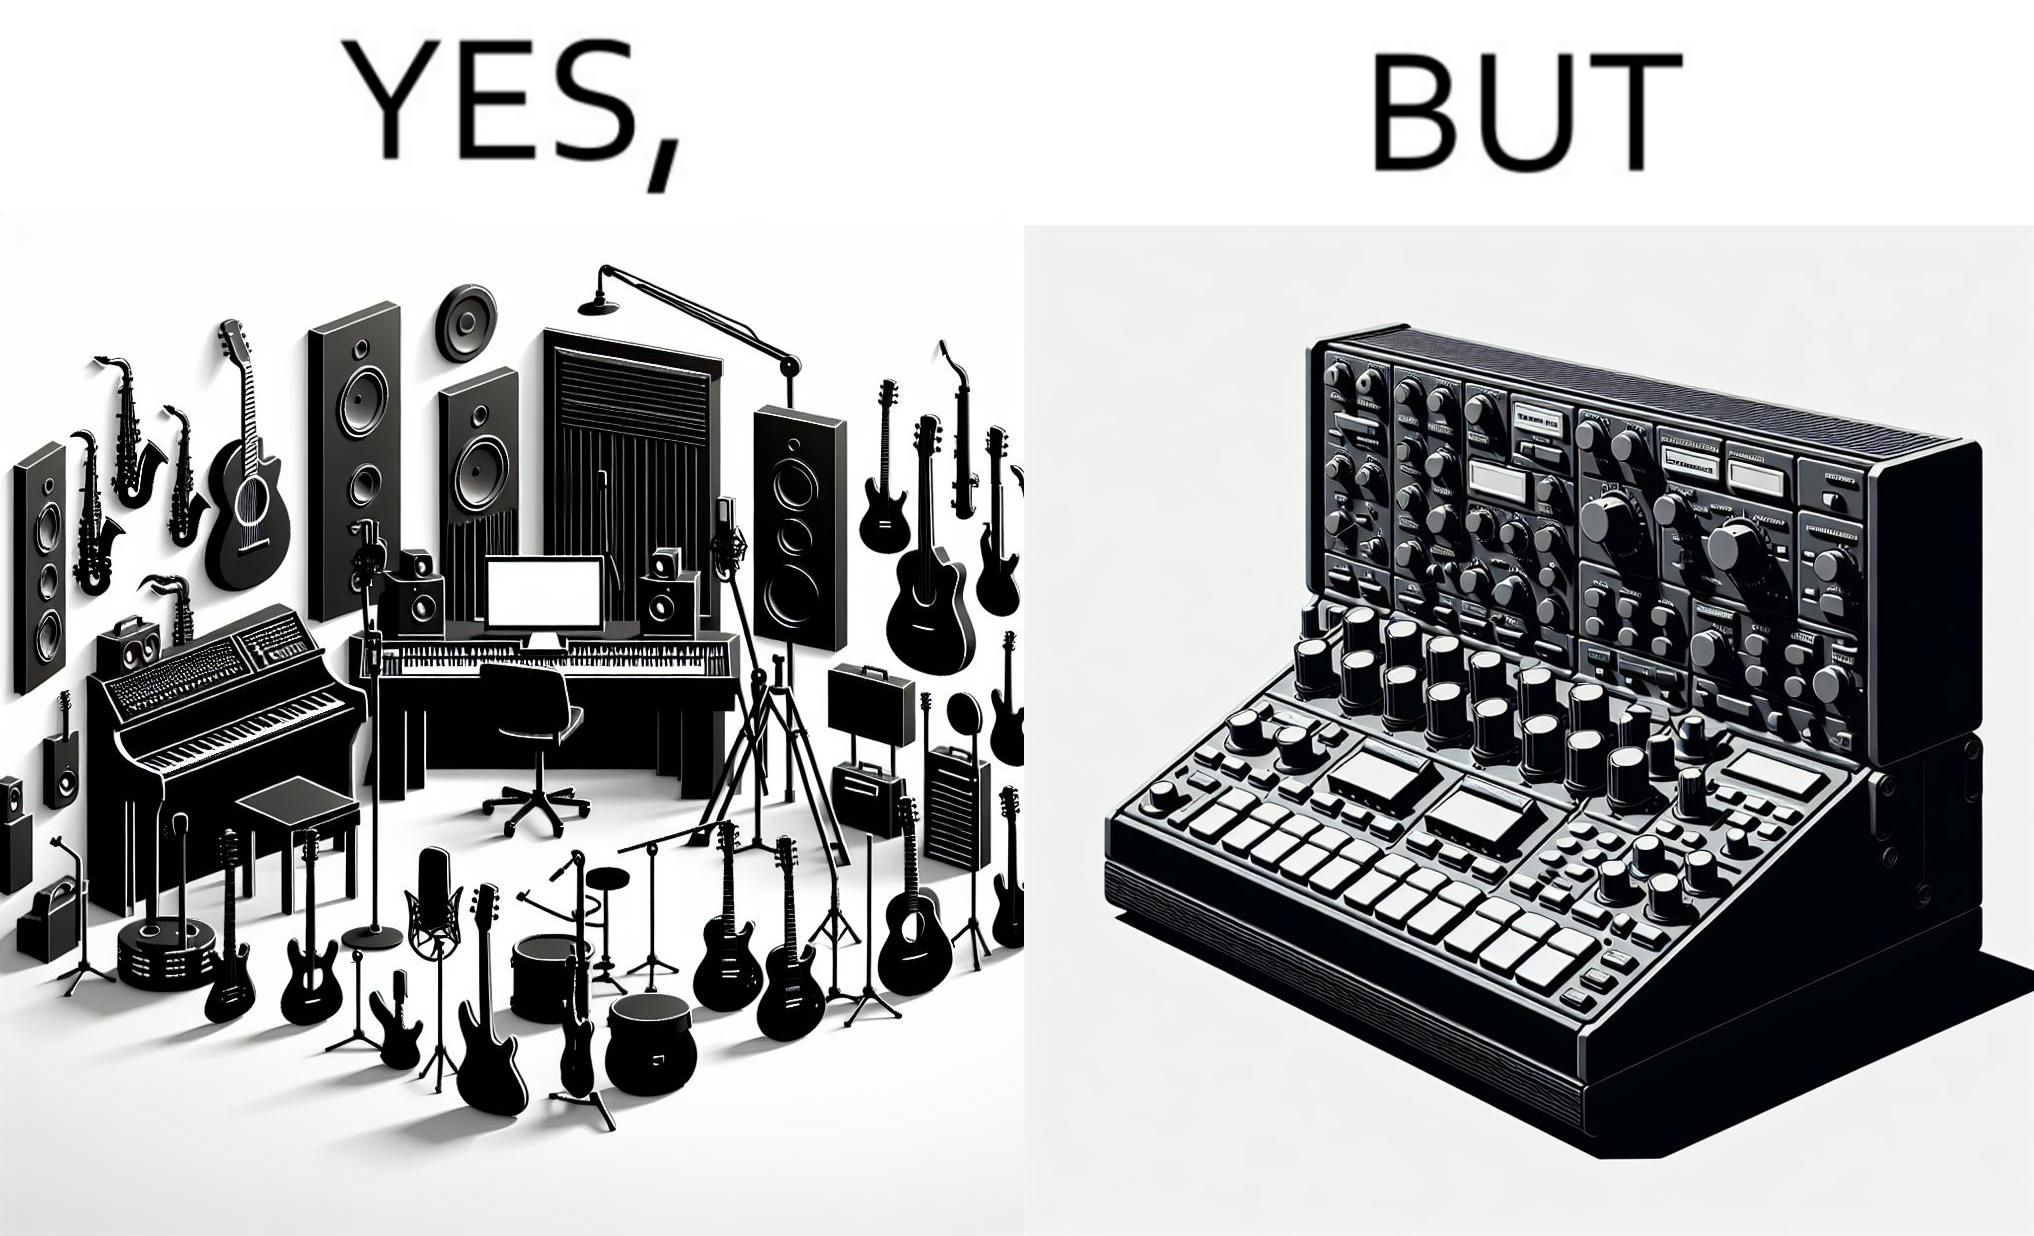Would you classify this image as satirical? Yes, this image is satirical. 